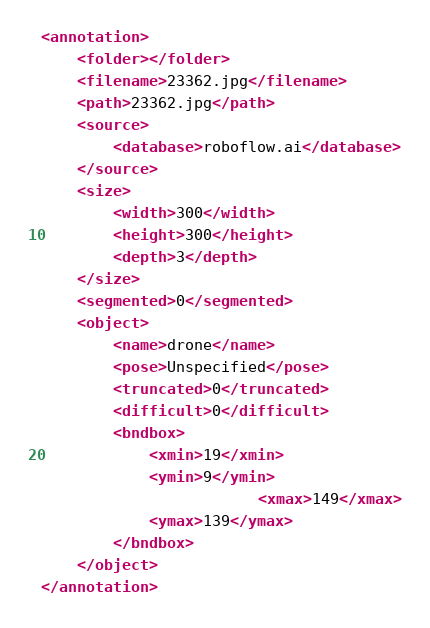Convert code to text. <code><loc_0><loc_0><loc_500><loc_500><_XML_><annotation>
	<folder></folder>
	<filename>23362.jpg</filename>
	<path>23362.jpg</path>
	<source>
		<database>roboflow.ai</database>
	</source>
	<size>
		<width>300</width>
		<height>300</height>
		<depth>3</depth>
	</size>
	<segmented>0</segmented>
	<object>
		<name>drone</name>
		<pose>Unspecified</pose>
		<truncated>0</truncated>
		<difficult>0</difficult>
		<bndbox>
			<xmin>19</xmin>
			<ymin>9</ymin>
                        <xmax>149</xmax>
			<ymax>139</ymax>
		</bndbox>
	</object>
</annotation>
</code> 